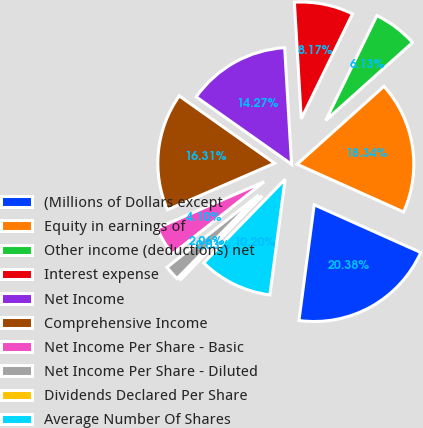<chart> <loc_0><loc_0><loc_500><loc_500><pie_chart><fcel>(Millions of Dollars except<fcel>Equity in earnings of<fcel>Other income (deductions) net<fcel>Interest expense<fcel>Net Income<fcel>Comprehensive Income<fcel>Net Income Per Share - Basic<fcel>Net Income Per Share - Diluted<fcel>Dividends Declared Per Share<fcel>Average Number Of Shares<nl><fcel>20.38%<fcel>18.34%<fcel>6.13%<fcel>8.17%<fcel>14.27%<fcel>16.31%<fcel>4.1%<fcel>2.06%<fcel>0.03%<fcel>10.2%<nl></chart> 